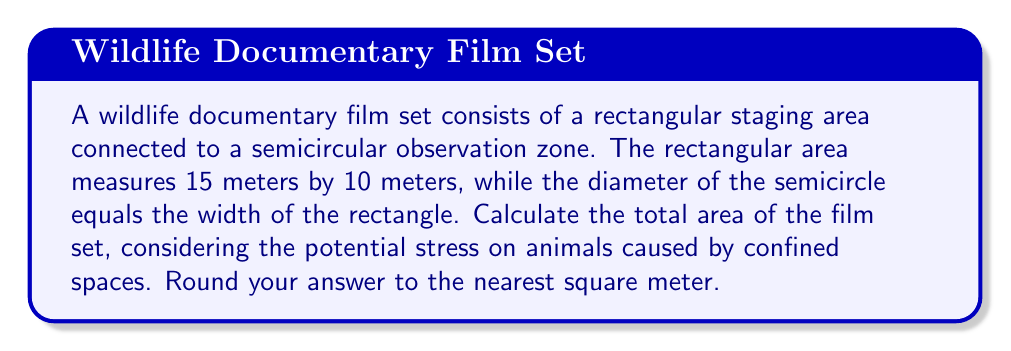Help me with this question. To calculate the total area of the film set, we need to find the sum of the areas of the rectangle and the semicircle.

1. Area of the rectangle:
   $$A_r = l \times w$$
   $$A_r = 15 \text{ m} \times 10 \text{ m} = 150 \text{ m}^2$$

2. Area of the semicircle:
   The diameter of the semicircle is equal to the width of the rectangle, which is 10 m.
   Therefore, the radius is 5 m.
   
   The formula for the area of a semicircle is:
   $$A_s = \frac{1}{2} \times \pi r^2$$
   
   $$A_s = \frac{1}{2} \times \pi \times (5 \text{ m})^2$$
   $$A_s = \frac{1}{2} \times \pi \times 25 \text{ m}^2$$
   $$A_s \approx 39.27 \text{ m}^2$$

3. Total area:
   $$A_{\text{total}} = A_r + A_s$$
   $$A_{\text{total}} = 150 \text{ m}^2 + 39.27 \text{ m}^2$$
   $$A_{\text{total}} \approx 189.27 \text{ m}^2$$

4. Rounding to the nearest square meter:
   $$A_{\text{total}} \approx 189 \text{ m}^2$$
Answer: 189 m² 